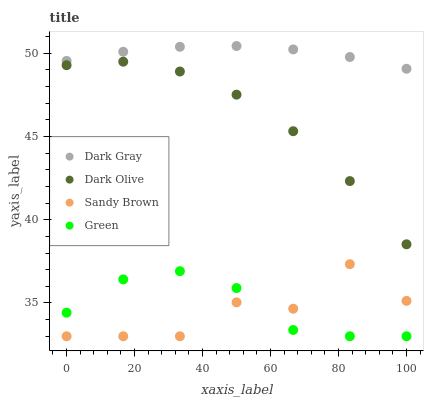Does Sandy Brown have the minimum area under the curve?
Answer yes or no. Yes. Does Dark Gray have the maximum area under the curve?
Answer yes or no. Yes. Does Green have the minimum area under the curve?
Answer yes or no. No. Does Green have the maximum area under the curve?
Answer yes or no. No. Is Dark Gray the smoothest?
Answer yes or no. Yes. Is Sandy Brown the roughest?
Answer yes or no. Yes. Is Green the smoothest?
Answer yes or no. No. Is Green the roughest?
Answer yes or no. No. Does Green have the lowest value?
Answer yes or no. Yes. Does Dark Olive have the lowest value?
Answer yes or no. No. Does Dark Gray have the highest value?
Answer yes or no. Yes. Does Dark Olive have the highest value?
Answer yes or no. No. Is Sandy Brown less than Dark Olive?
Answer yes or no. Yes. Is Dark Gray greater than Dark Olive?
Answer yes or no. Yes. Does Green intersect Sandy Brown?
Answer yes or no. Yes. Is Green less than Sandy Brown?
Answer yes or no. No. Is Green greater than Sandy Brown?
Answer yes or no. No. Does Sandy Brown intersect Dark Olive?
Answer yes or no. No. 